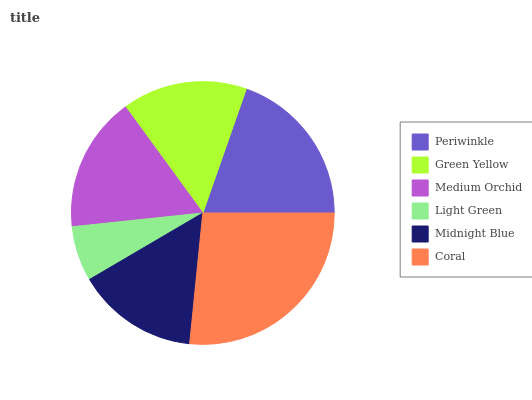Is Light Green the minimum?
Answer yes or no. Yes. Is Coral the maximum?
Answer yes or no. Yes. Is Green Yellow the minimum?
Answer yes or no. No. Is Green Yellow the maximum?
Answer yes or no. No. Is Periwinkle greater than Green Yellow?
Answer yes or no. Yes. Is Green Yellow less than Periwinkle?
Answer yes or no. Yes. Is Green Yellow greater than Periwinkle?
Answer yes or no. No. Is Periwinkle less than Green Yellow?
Answer yes or no. No. Is Medium Orchid the high median?
Answer yes or no. Yes. Is Green Yellow the low median?
Answer yes or no. Yes. Is Green Yellow the high median?
Answer yes or no. No. Is Midnight Blue the low median?
Answer yes or no. No. 